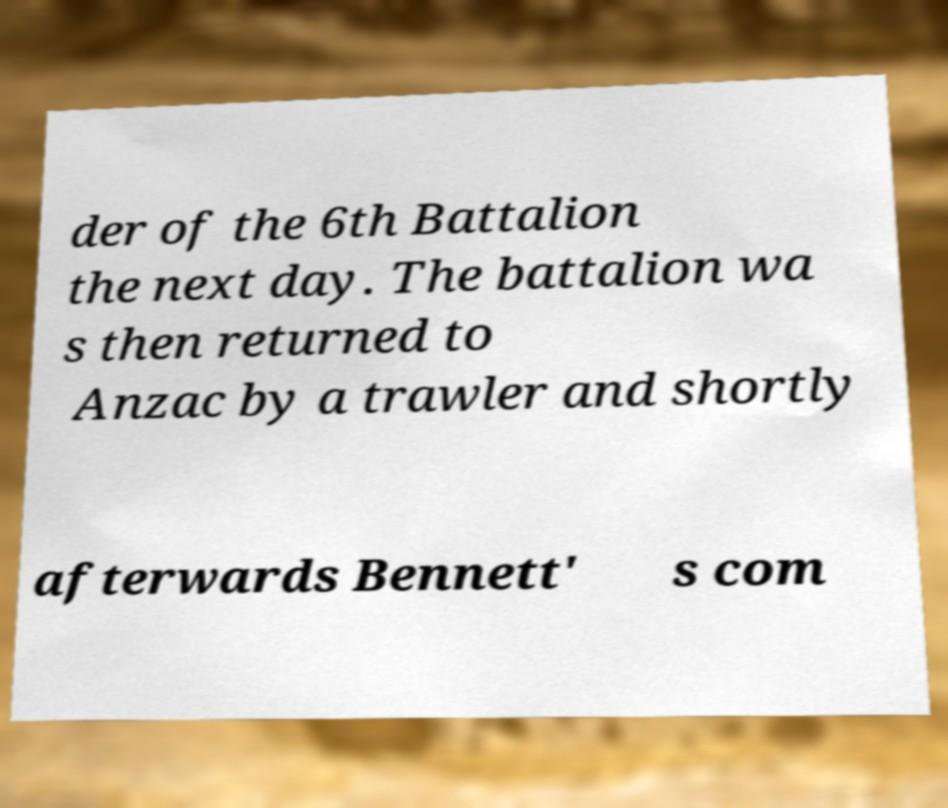Could you extract and type out the text from this image? der of the 6th Battalion the next day. The battalion wa s then returned to Anzac by a trawler and shortly afterwards Bennett' s com 